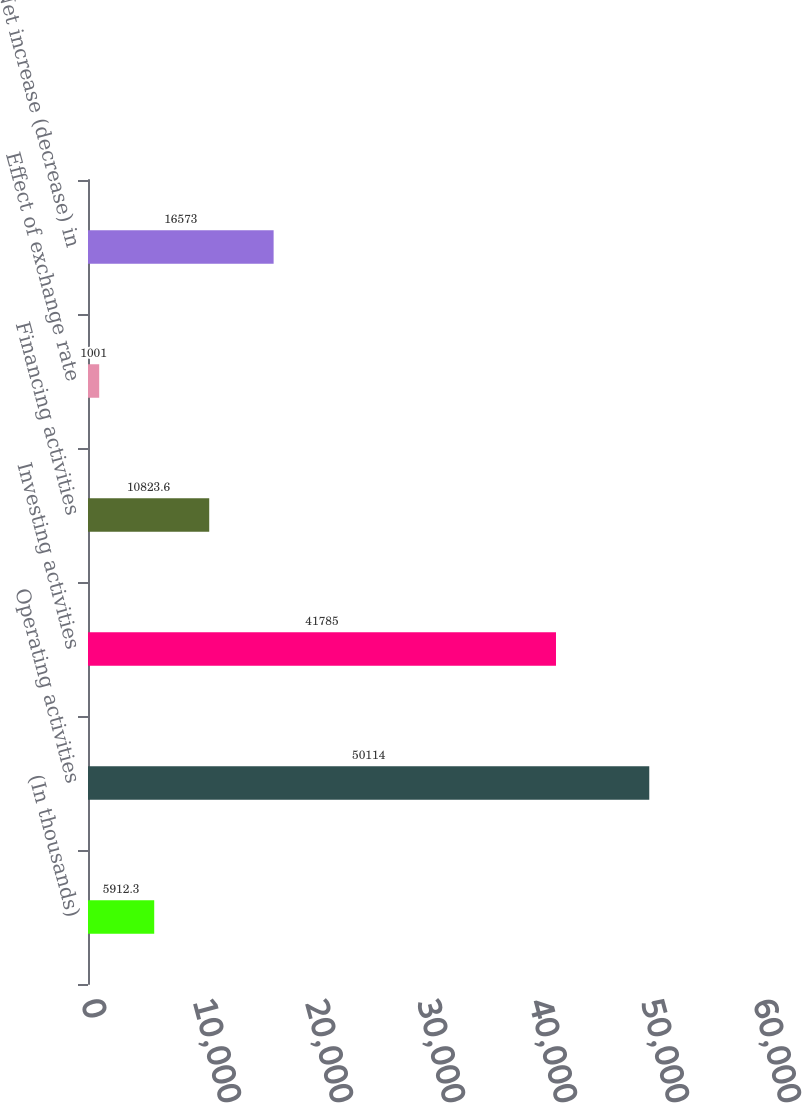Convert chart. <chart><loc_0><loc_0><loc_500><loc_500><bar_chart><fcel>(In thousands)<fcel>Operating activities<fcel>Investing activities<fcel>Financing activities<fcel>Effect of exchange rate<fcel>Net increase (decrease) in<nl><fcel>5912.3<fcel>50114<fcel>41785<fcel>10823.6<fcel>1001<fcel>16573<nl></chart> 